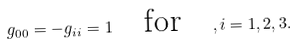<formula> <loc_0><loc_0><loc_500><loc_500>g _ { 0 0 } = - g _ { i i } = 1 \quad \text {for} \quad , i = 1 , 2 , 3 .</formula> 